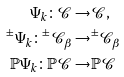<formula> <loc_0><loc_0><loc_500><loc_500>\Psi _ { k } \colon \mathcal { C } \to & \mathcal { C } , \\ ^ { \pm } \Psi _ { k } \colon ^ { \pm } \mathcal { C } _ { \beta } \to & ^ { \pm } \mathcal { C } _ { \beta } \\ \mathbb { P } \Psi _ { k } \colon \mathbb { P } \mathcal { C } \to & \mathbb { P } \mathcal { C }</formula> 